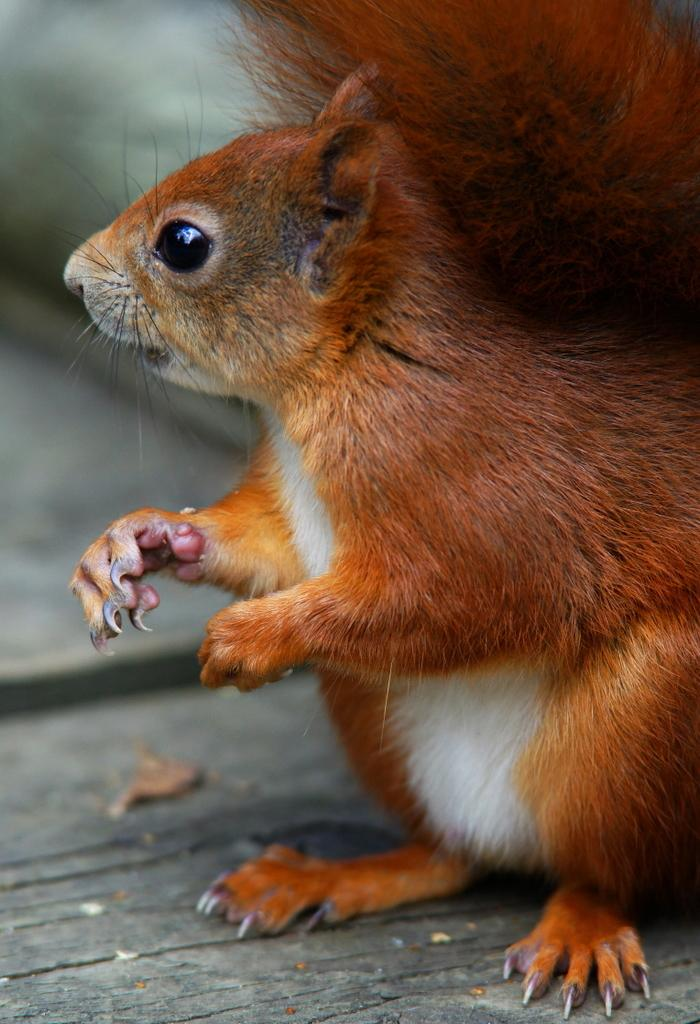What type of animal is in the image? There is a squirrel in the image. What surface is the squirrel on? The squirrel is on a wooden surface. Can you describe the background of the image? The background of the image is blurred. Where does the squirrel go to take a nap in the image? There is no indication in the image that the squirrel is taking a nap or going anywhere. What type of food is the squirrel eating in the lunchroom in the image? There is no lunchroom or food present in the image; it features a squirrel on a wooden surface with a blurred background. 